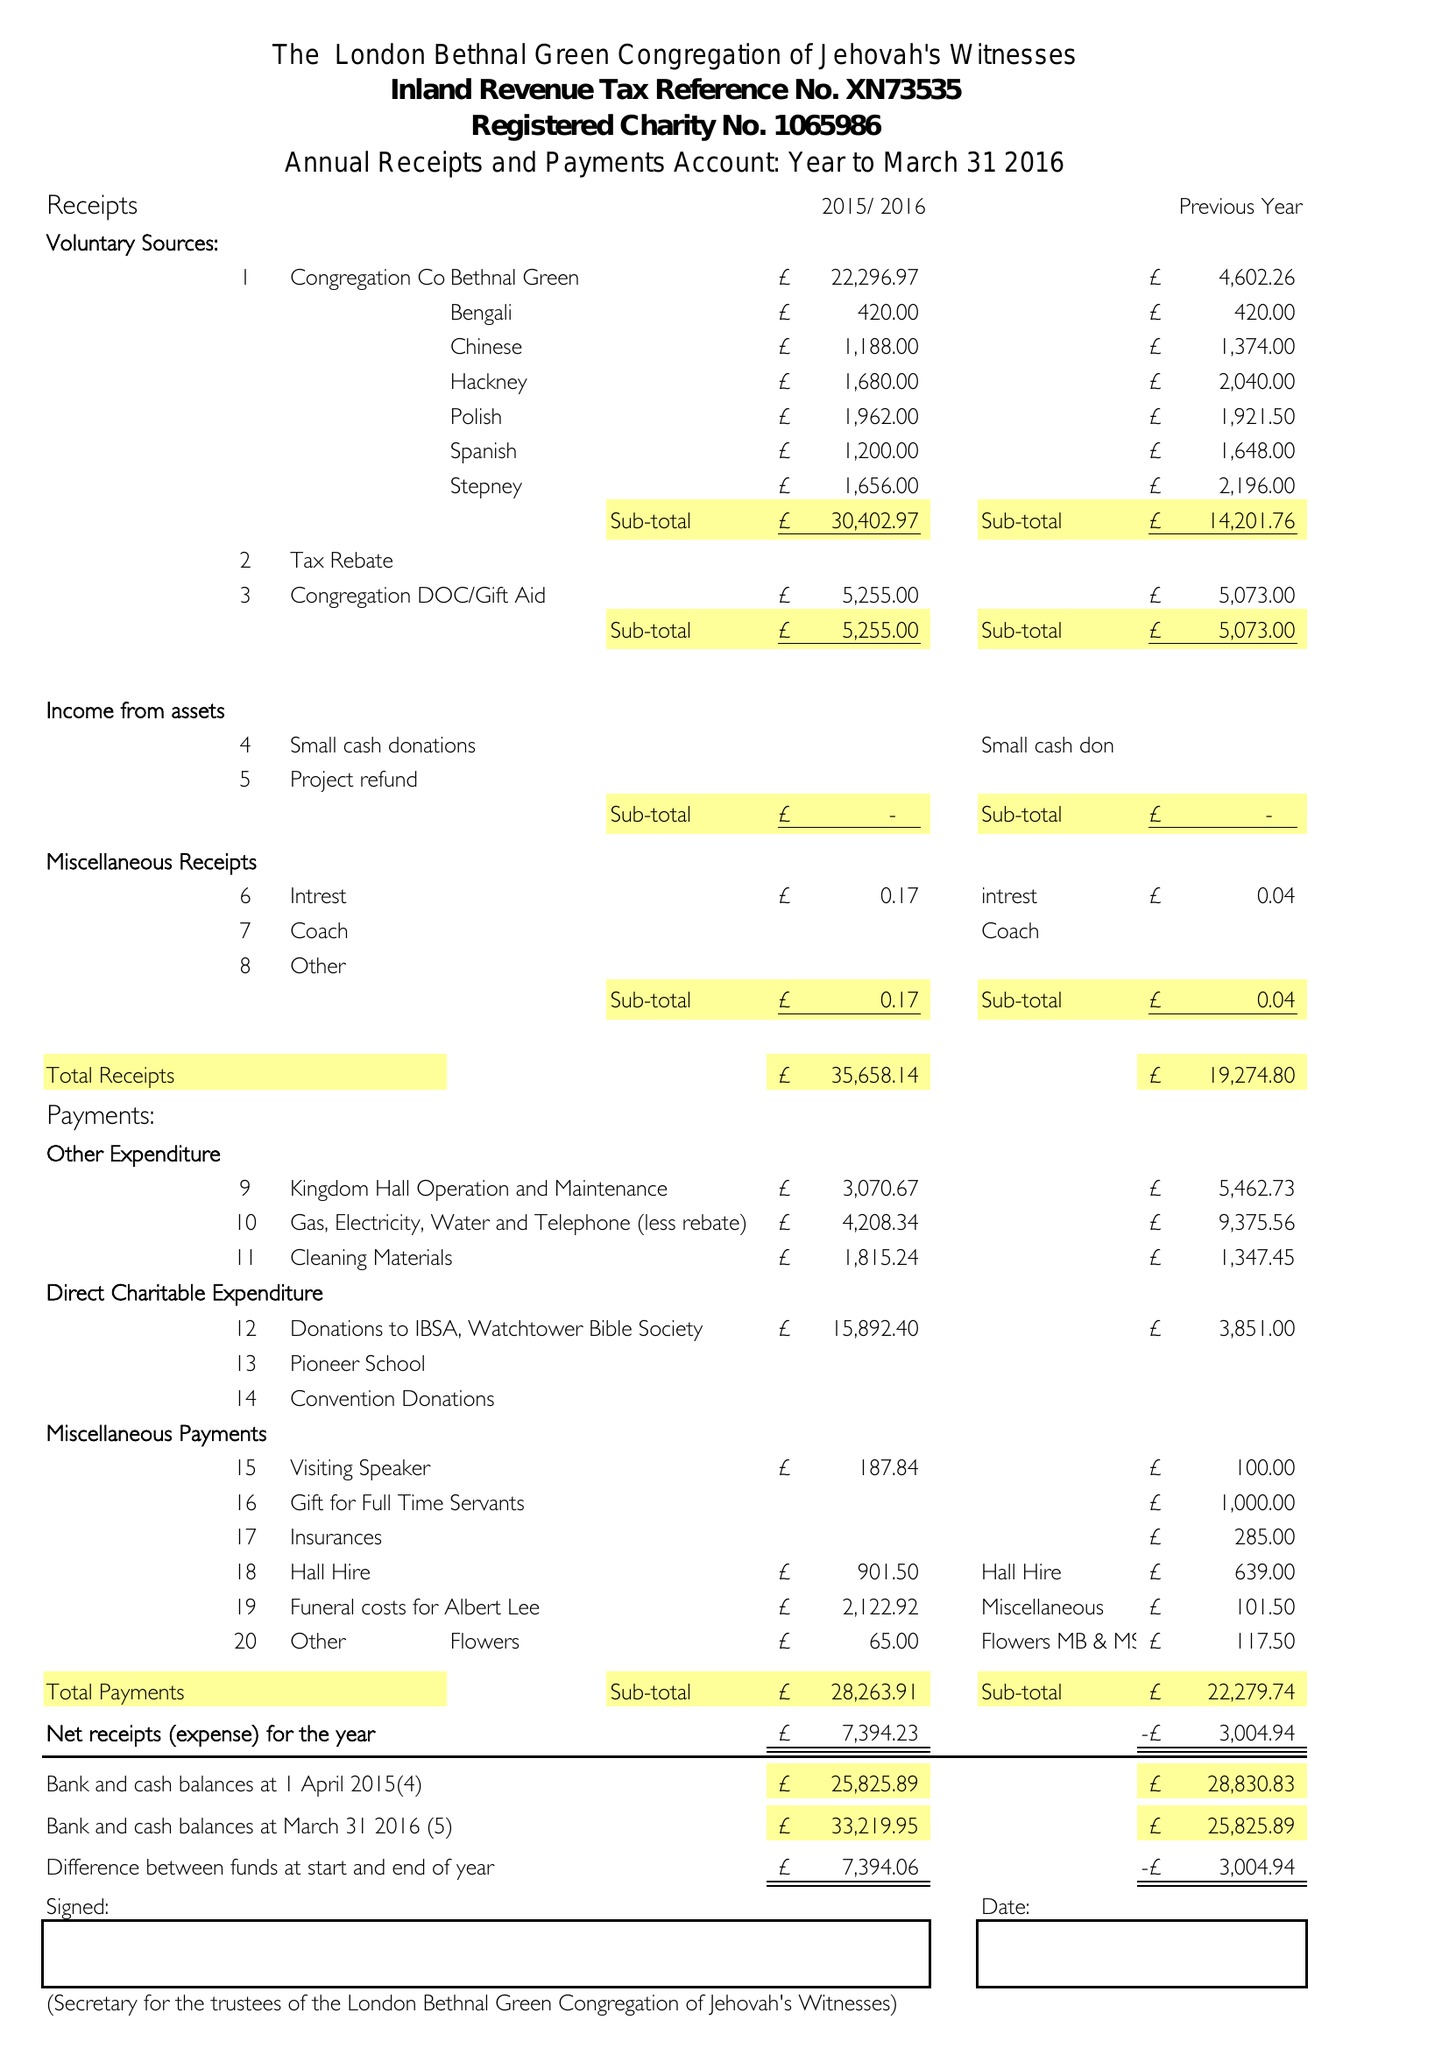What is the value for the charity_name?
Answer the question using a single word or phrase. London, Bethnal Green Congregation Of Jehovah's Witnesses 